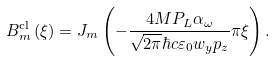<formula> <loc_0><loc_0><loc_500><loc_500>B _ { m } ^ { \text {cl} } \left ( \xi \right ) = J _ { m } \left ( - \frac { 4 M P _ { L } \alpha _ { \omega } } { \sqrt { 2 \pi } \hbar { c } \varepsilon _ { 0 } w _ { y } p _ { z } } \pi \xi \right ) .</formula> 